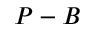Convert formula to latex. <formula><loc_0><loc_0><loc_500><loc_500>P - B</formula> 